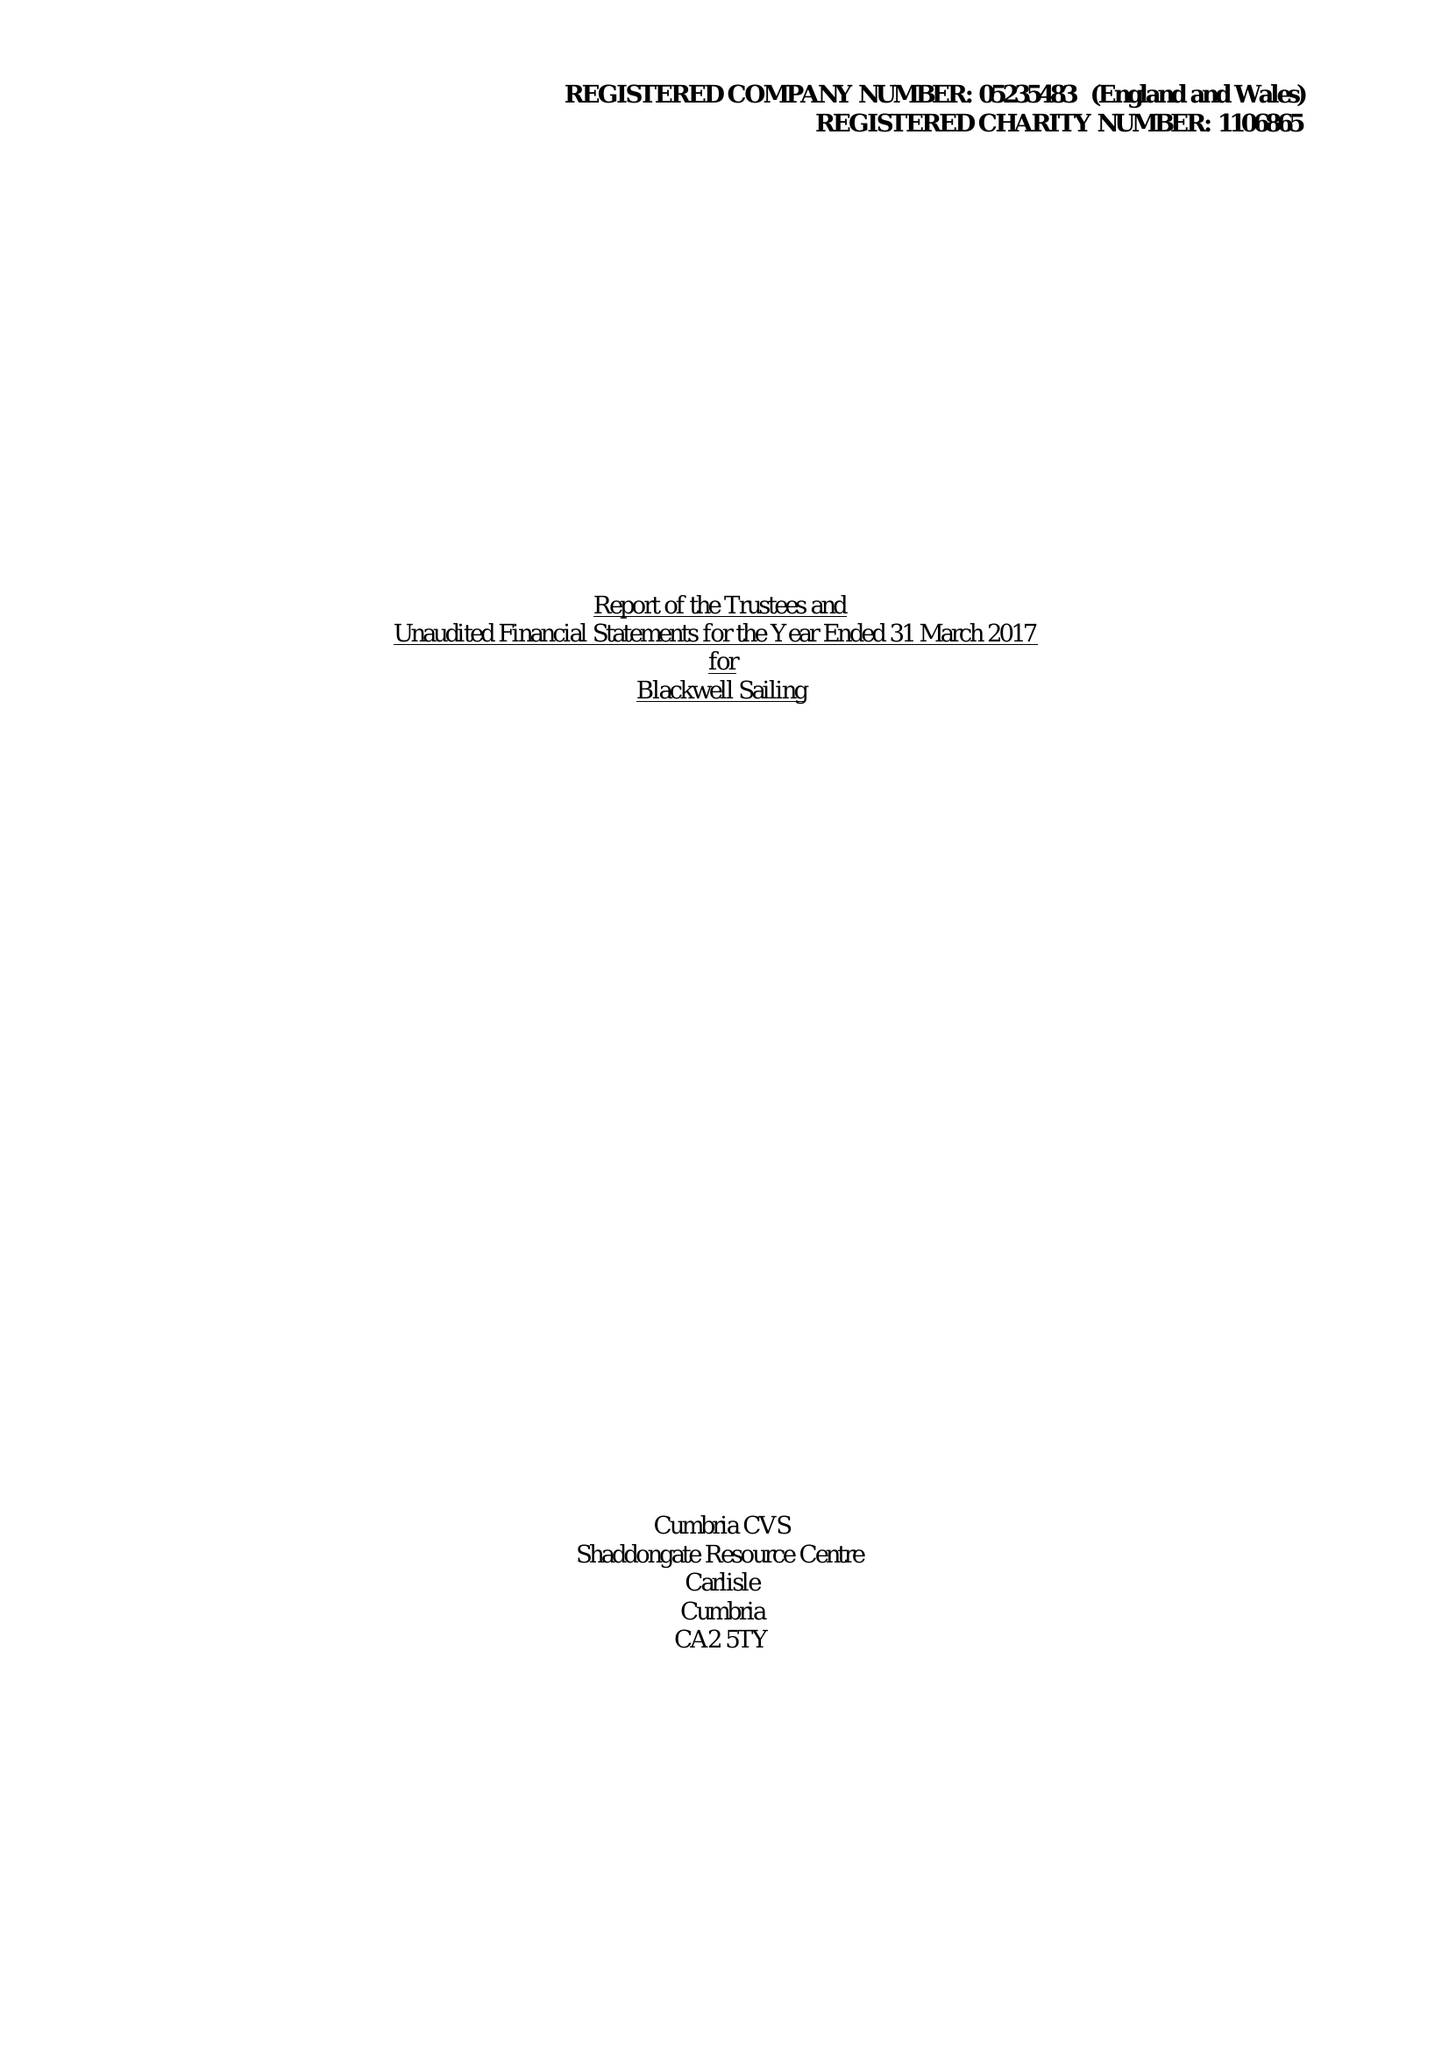What is the value for the address__street_line?
Answer the question using a single word or phrase. GLEBE ROAD 